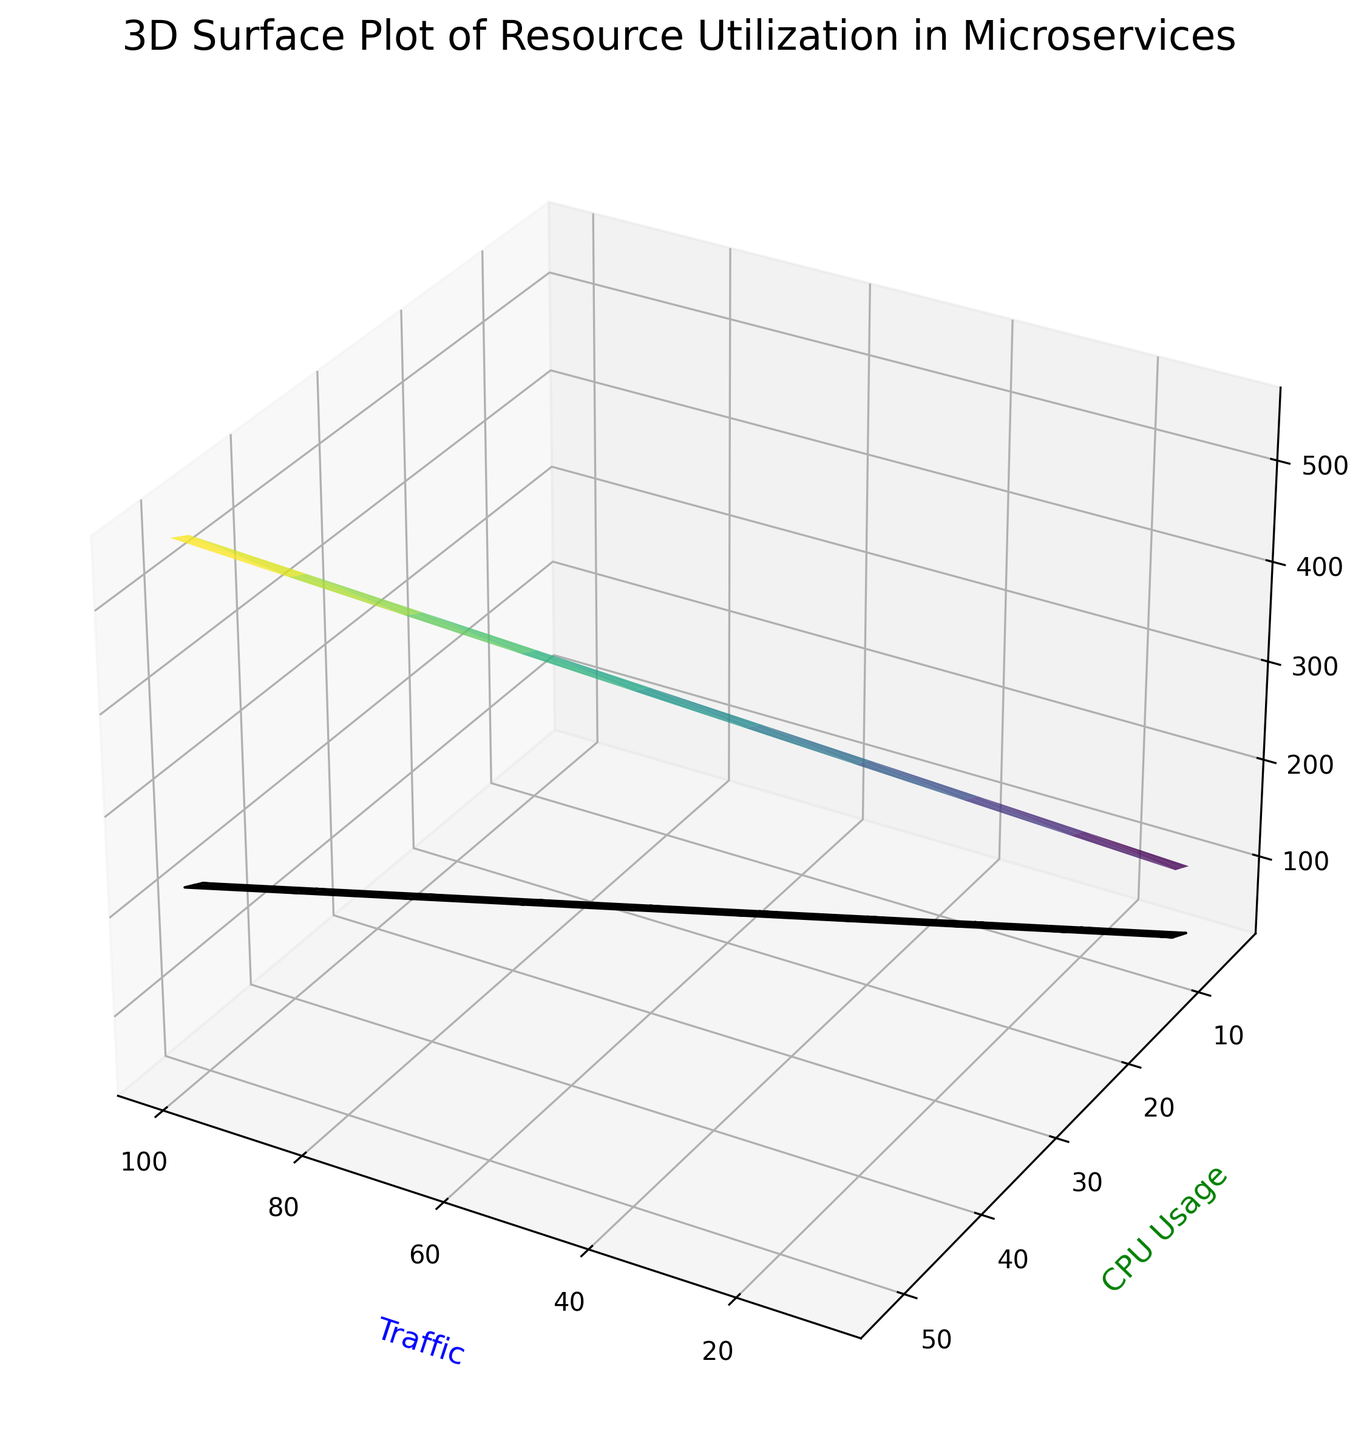How does CPU usage change as traffic increases from 10 to 60? To determine the change in CPU usage, observe the CPU values corresponding to traffic values from 10 to 60. As traffic moves from 10 to 60, CPU usage increases steadily from around 5 to 32.
Answer: CPU usage rises Which variable (memory or IO) grows faster with increasing traffic? By comparing the slopes of the surfaces, identify the steeper gradient. The memory surface (in viridis color) grows more noticeably steeper than the IO surface (in plasma color) as traffic increases, indicating that memory usage grows faster.
Answer: Memory What is the memory utilization when traffic is 50 and CPU usage is at its maximum for that traffic? Find the memory utilization corresponding to the highest CPU value at traffic = 50 (CPU = 27). With traffic at 50, memory usage at the highest CPU value is 310.
Answer: 310 At what traffic value does CPU usage first exceed 20? Look for the intersection point where the CPU curve crosses the 20 mark along the traffic axis. This happens when the traffic is between 30 and 40.
Answer: Between 30 and 40 What is the approximate IO utilization for the highest traffic value on the plot? Locate the IO value corresponding to the highest traffic value (100). The IO utilization at traffic = 100 is approximately 220.
Answer: 220 